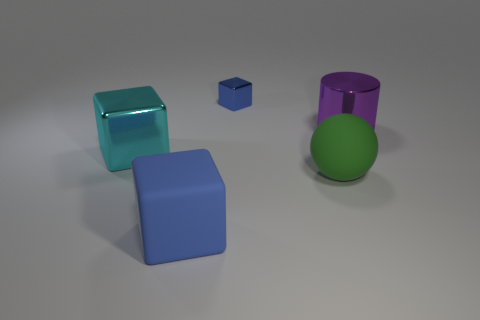Add 1 big green things. How many objects exist? 6 Subtract all cubes. How many objects are left? 2 Subtract all large green matte things. Subtract all large purple metallic cylinders. How many objects are left? 3 Add 1 large objects. How many large objects are left? 5 Add 4 large green things. How many large green things exist? 5 Subtract 0 brown cylinders. How many objects are left? 5 